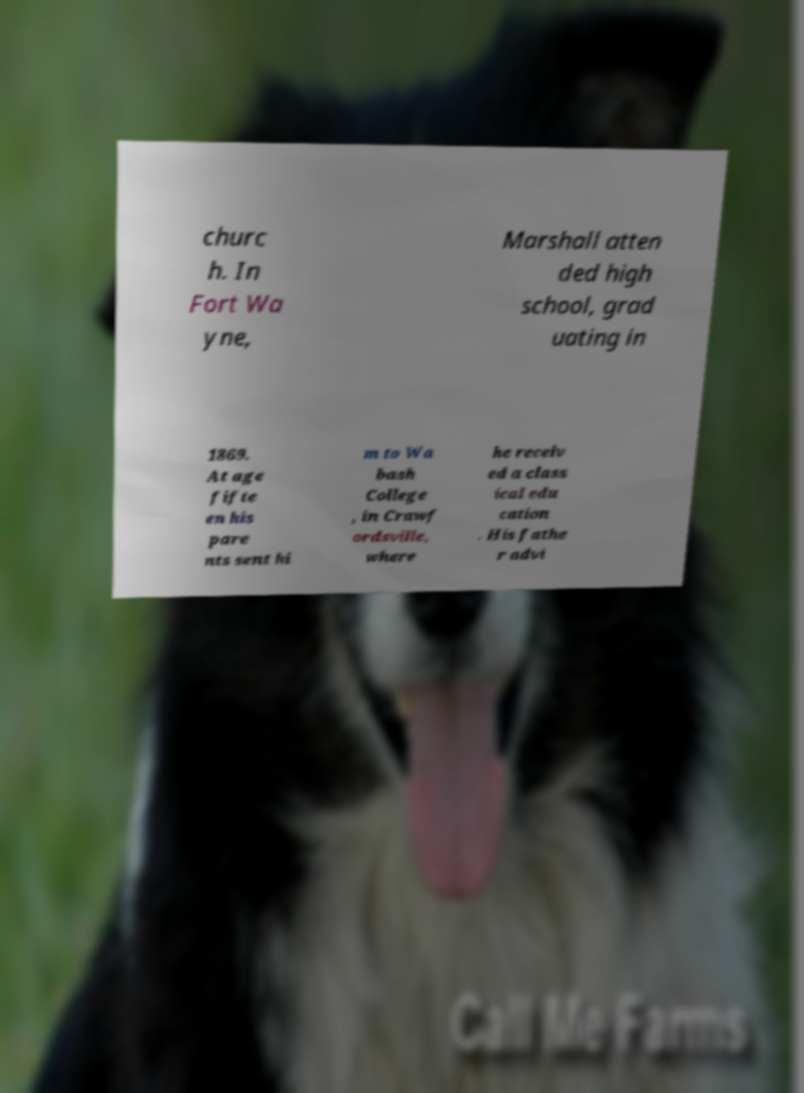I need the written content from this picture converted into text. Can you do that? churc h. In Fort Wa yne, Marshall atten ded high school, grad uating in 1869. At age fifte en his pare nts sent hi m to Wa bash College , in Crawf ordsville, where he receiv ed a class ical edu cation . His fathe r advi 